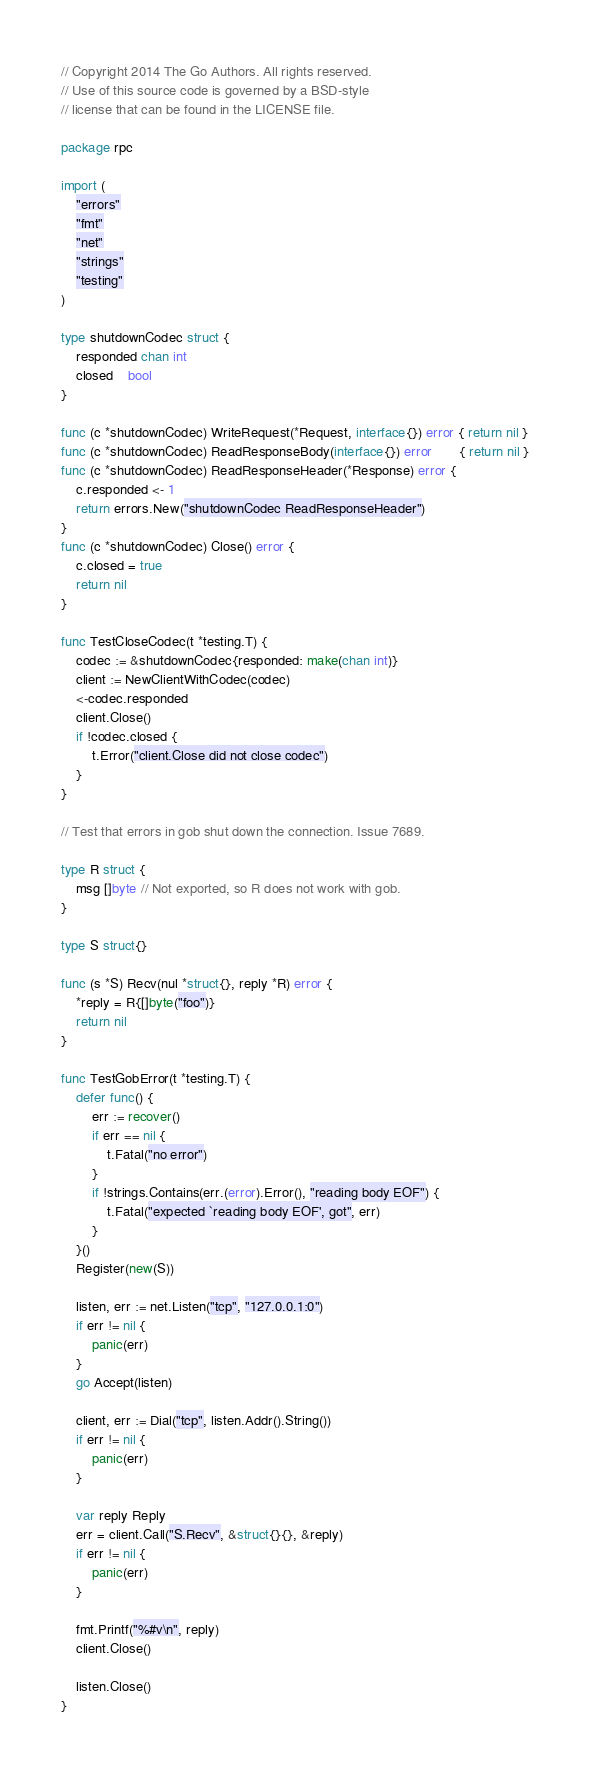Convert code to text. <code><loc_0><loc_0><loc_500><loc_500><_Go_>// Copyright 2014 The Go Authors. All rights reserved.
// Use of this source code is governed by a BSD-style
// license that can be found in the LICENSE file.

package rpc

import (
	"errors"
	"fmt"
	"net"
	"strings"
	"testing"
)

type shutdownCodec struct {
	responded chan int
	closed    bool
}

func (c *shutdownCodec) WriteRequest(*Request, interface{}) error { return nil }
func (c *shutdownCodec) ReadResponseBody(interface{}) error       { return nil }
func (c *shutdownCodec) ReadResponseHeader(*Response) error {
	c.responded <- 1
	return errors.New("shutdownCodec ReadResponseHeader")
}
func (c *shutdownCodec) Close() error {
	c.closed = true
	return nil
}

func TestCloseCodec(t *testing.T) {
	codec := &shutdownCodec{responded: make(chan int)}
	client := NewClientWithCodec(codec)
	<-codec.responded
	client.Close()
	if !codec.closed {
		t.Error("client.Close did not close codec")
	}
}

// Test that errors in gob shut down the connection. Issue 7689.

type R struct {
	msg []byte // Not exported, so R does not work with gob.
}

type S struct{}

func (s *S) Recv(nul *struct{}, reply *R) error {
	*reply = R{[]byte("foo")}
	return nil
}

func TestGobError(t *testing.T) {
	defer func() {
		err := recover()
		if err == nil {
			t.Fatal("no error")
		}
		if !strings.Contains(err.(error).Error(), "reading body EOF") {
			t.Fatal("expected `reading body EOF', got", err)
		}
	}()
	Register(new(S))

	listen, err := net.Listen("tcp", "127.0.0.1:0")
	if err != nil {
		panic(err)
	}
	go Accept(listen)

	client, err := Dial("tcp", listen.Addr().String())
	if err != nil {
		panic(err)
	}

	var reply Reply
	err = client.Call("S.Recv", &struct{}{}, &reply)
	if err != nil {
		panic(err)
	}

	fmt.Printf("%#v\n", reply)
	client.Close()

	listen.Close()
}
</code> 